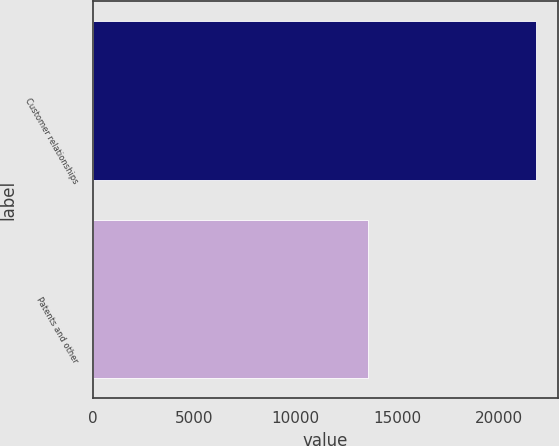<chart> <loc_0><loc_0><loc_500><loc_500><bar_chart><fcel>Customer relationships<fcel>Patents and other<nl><fcel>21828<fcel>13548<nl></chart> 